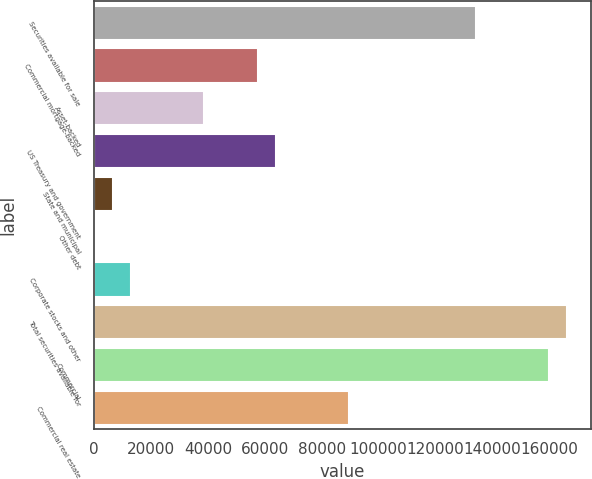Convert chart to OTSL. <chart><loc_0><loc_0><loc_500><loc_500><bar_chart><fcel>Securities available for sale<fcel>Commercial mortgage-backed<fcel>Asset-backed<fcel>US Treasury and government<fcel>State and municipal<fcel>Other debt<fcel>Corporate stocks and other<fcel>Total securities available for<fcel>Commercial<fcel>Commercial real estate<nl><fcel>134369<fcel>57637.7<fcel>38454.8<fcel>64032<fcel>6483.3<fcel>89<fcel>12877.6<fcel>166341<fcel>159946<fcel>89609.2<nl></chart> 